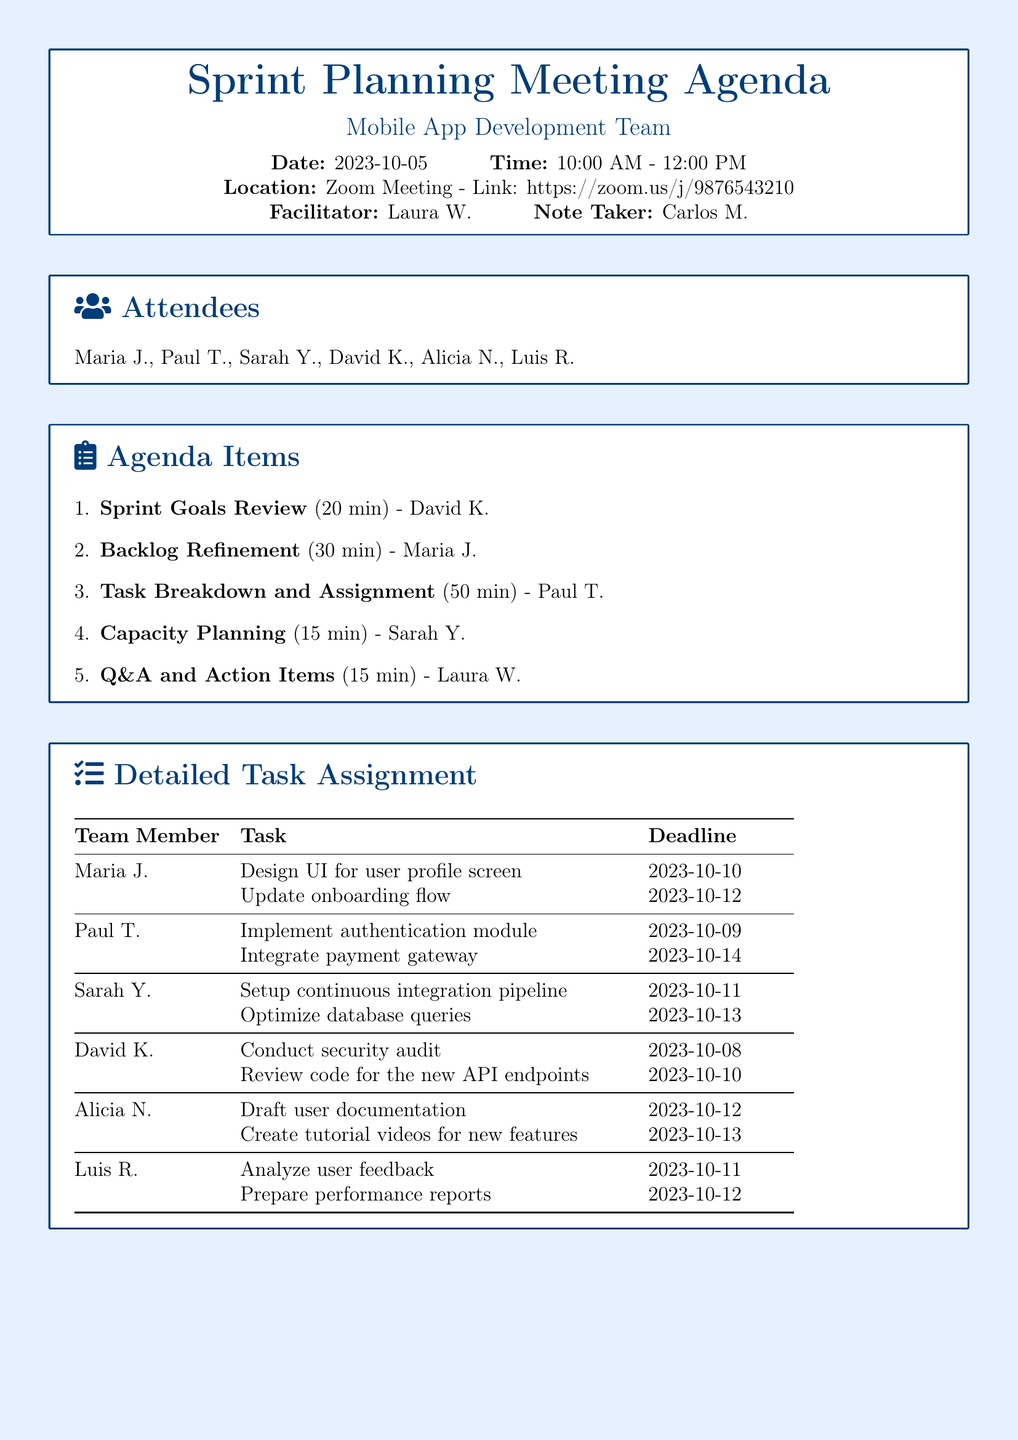What is the date of the Sprint Planning Meeting? The date is explicitly mentioned in the document as part of the meeting details.
Answer: 2023-10-05 Who is the Note Taker for the meeting? The document specifies the roles of individuals involved, including the Note Taker.
Answer: Carlos M How long is the Task Breakdown and Assignment agenda item scheduled for? The duration of each agenda item is noted in the list of agenda items.
Answer: 50 min What task is Maria J. assigned to complete by October 12? The document lists tasks assigned to team members, including Maria J.'s specific deadlines.
Answer: Update onboarding flow Who is responsible for the security audit? The task assignment table provides a clear breakdown of responsibilities among team members.
Answer: David K How many tasks does Paul T. have assigned to him? The document lists each team member and their respective tasks, indicating the count for Paul T.
Answer: 2 What is the deadline for optimizing database queries? The deadline for each task assigned to team members is detailed in the task assignment section of the document.
Answer: 2023-10-13 What is the location for the Sprint Planning Meeting? The meeting location is clearly stated in the meeting details.
Answer: Zoom Meeting - Link: https://zoom.us/j/9876543210 How many attendees are listed in the document? The document provides the names of those present at the meeting, indicating the total count.
Answer: 6 